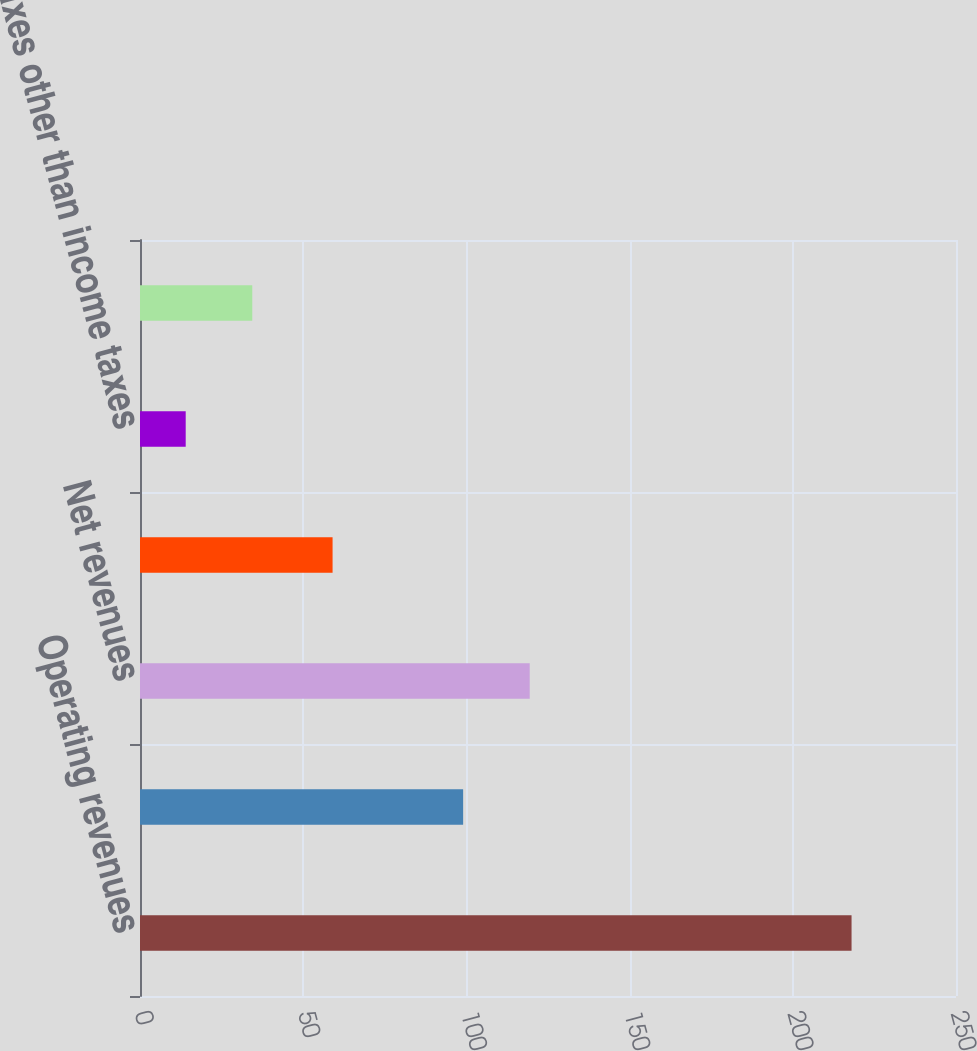Convert chart to OTSL. <chart><loc_0><loc_0><loc_500><loc_500><bar_chart><fcel>Operating revenues<fcel>Gas purchased for resale<fcel>Net revenues<fcel>Operations and maintenance<fcel>Taxes other than income taxes<fcel>Gas operating income<nl><fcel>218<fcel>99<fcel>119.4<fcel>59<fcel>14<fcel>34.4<nl></chart> 